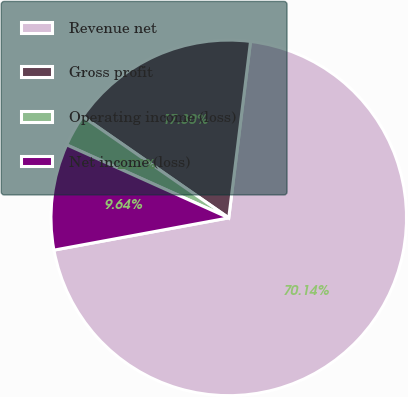Convert chart. <chart><loc_0><loc_0><loc_500><loc_500><pie_chart><fcel>Revenue net � � � � � � � � �<fcel>Gross profit � � � � � � � � �<fcel>Operating income (loss) � � �<fcel>Net income (loss) � � � � � �<nl><fcel>70.14%<fcel>17.3%<fcel>2.92%<fcel>9.64%<nl></chart> 